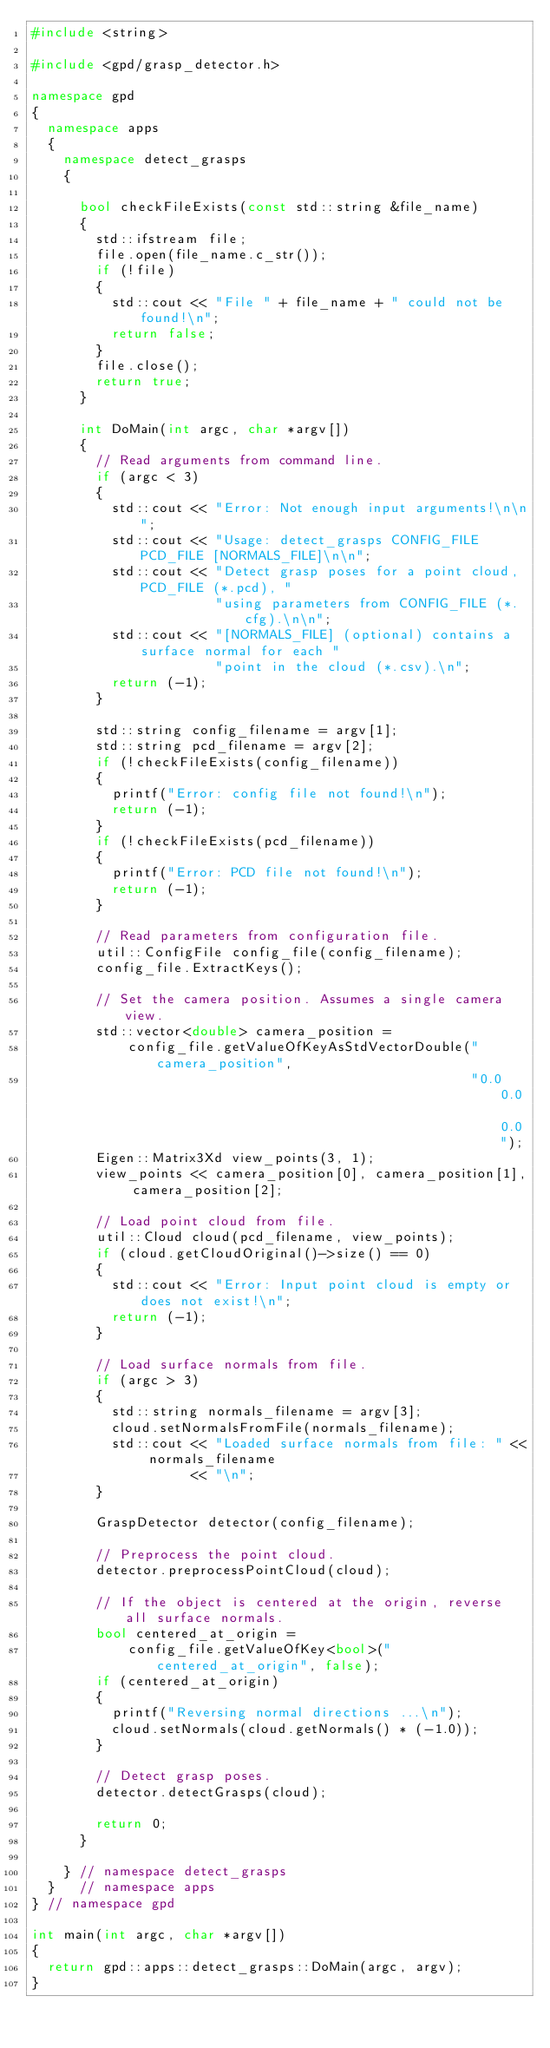Convert code to text. <code><loc_0><loc_0><loc_500><loc_500><_C++_>#include <string>

#include <gpd/grasp_detector.h>

namespace gpd
{
  namespace apps
  {
    namespace detect_grasps
    {

      bool checkFileExists(const std::string &file_name)
      {
        std::ifstream file;
        file.open(file_name.c_str());
        if (!file)
        {
          std::cout << "File " + file_name + " could not be found!\n";
          return false;
        }
        file.close();
        return true;
      }

      int DoMain(int argc, char *argv[])
      {
        // Read arguments from command line.
        if (argc < 3)
        {
          std::cout << "Error: Not enough input arguments!\n\n";
          std::cout << "Usage: detect_grasps CONFIG_FILE PCD_FILE [NORMALS_FILE]\n\n";
          std::cout << "Detect grasp poses for a point cloud, PCD_FILE (*.pcd), "
                       "using parameters from CONFIG_FILE (*.cfg).\n\n";
          std::cout << "[NORMALS_FILE] (optional) contains a surface normal for each "
                       "point in the cloud (*.csv).\n";
          return (-1);
        }

        std::string config_filename = argv[1];
        std::string pcd_filename = argv[2];
        if (!checkFileExists(config_filename))
        {
          printf("Error: config file not found!\n");
          return (-1);
        }
        if (!checkFileExists(pcd_filename))
        {
          printf("Error: PCD file not found!\n");
          return (-1);
        }

        // Read parameters from configuration file.
        util::ConfigFile config_file(config_filename);
        config_file.ExtractKeys();

        // Set the camera position. Assumes a single camera view.
        std::vector<double> camera_position =
            config_file.getValueOfKeyAsStdVectorDouble("camera_position",
                                                       "0.0 0.0 0.0");
        Eigen::Matrix3Xd view_points(3, 1);
        view_points << camera_position[0], camera_position[1], camera_position[2];

        // Load point cloud from file.
        util::Cloud cloud(pcd_filename, view_points);
        if (cloud.getCloudOriginal()->size() == 0)
        {
          std::cout << "Error: Input point cloud is empty or does not exist!\n";
          return (-1);
        }

        // Load surface normals from file.
        if (argc > 3)
        {
          std::string normals_filename = argv[3];
          cloud.setNormalsFromFile(normals_filename);
          std::cout << "Loaded surface normals from file: " << normals_filename
                    << "\n";
        }

        GraspDetector detector(config_filename);

        // Preprocess the point cloud.
        detector.preprocessPointCloud(cloud);

        // If the object is centered at the origin, reverse all surface normals.
        bool centered_at_origin =
            config_file.getValueOfKey<bool>("centered_at_origin", false);
        if (centered_at_origin)
        {
          printf("Reversing normal directions ...\n");
          cloud.setNormals(cloud.getNormals() * (-1.0));
        }

        // Detect grasp poses.
        detector.detectGrasps(cloud);

        return 0;
      }

    } // namespace detect_grasps
  }   // namespace apps
} // namespace gpd

int main(int argc, char *argv[])
{
  return gpd::apps::detect_grasps::DoMain(argc, argv);
}
</code> 